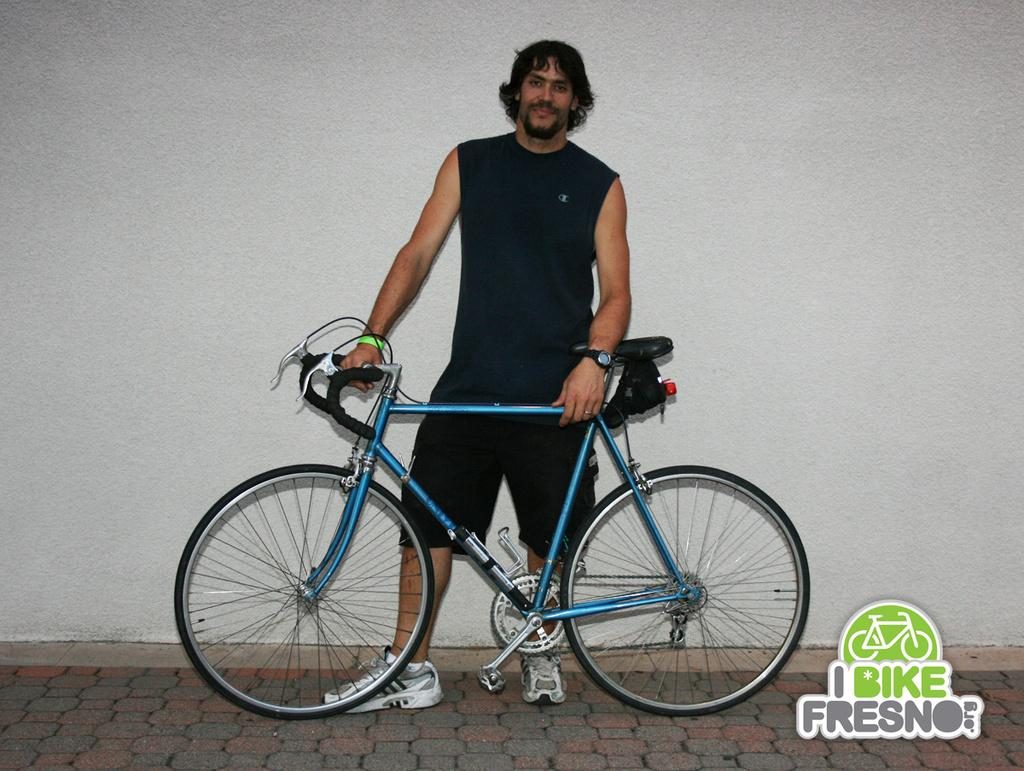What is the main subject of the image? The main subject of the image is a man. What is the man doing in the image? The man is standing and holding a bicycle. What color are the man's clothes and shoes? The man is wearing black color clothes and black color shoes. What can be seen in the background of the image? There is a wall in the background of the image. Is there any branding or symbol visible in the image? Yes, there is a logo visible in the image. What type of crayon is the man using to draw on the church in the image? There is no crayon or church present in the image. What degree does the man have, as indicated by the logo in the image? The logo in the image does not indicate any degree or educational qualification. 